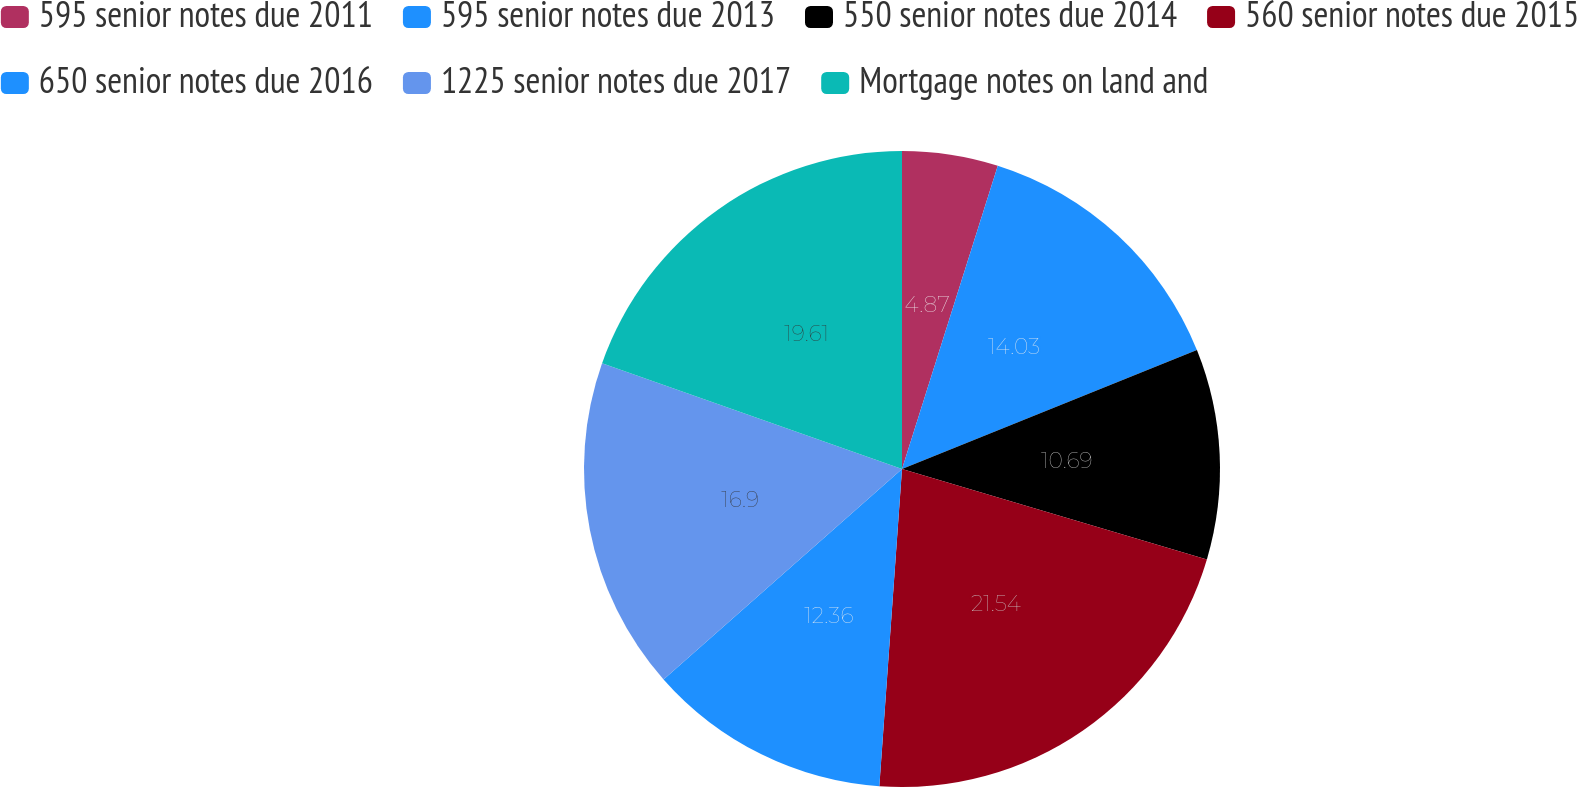Convert chart to OTSL. <chart><loc_0><loc_0><loc_500><loc_500><pie_chart><fcel>595 senior notes due 2011<fcel>595 senior notes due 2013<fcel>550 senior notes due 2014<fcel>560 senior notes due 2015<fcel>650 senior notes due 2016<fcel>1225 senior notes due 2017<fcel>Mortgage notes on land and<nl><fcel>4.87%<fcel>14.03%<fcel>10.69%<fcel>21.55%<fcel>12.36%<fcel>16.9%<fcel>19.61%<nl></chart> 